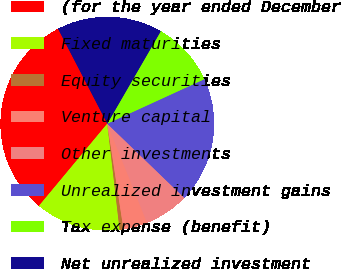<chart> <loc_0><loc_0><loc_500><loc_500><pie_chart><fcel>(for the year ended December<fcel>Fixed maturities<fcel>Equity securities<fcel>Venture capital<fcel>Other investments<fcel>Unrealized investment gains<fcel>Tax expense (benefit)<fcel>Net unrealized investment<nl><fcel>31.34%<fcel>12.88%<fcel>0.58%<fcel>3.65%<fcel>6.73%<fcel>19.04%<fcel>9.81%<fcel>15.96%<nl></chart> 